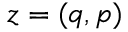Convert formula to latex. <formula><loc_0><loc_0><loc_500><loc_500>{ z } = ( q , p )</formula> 